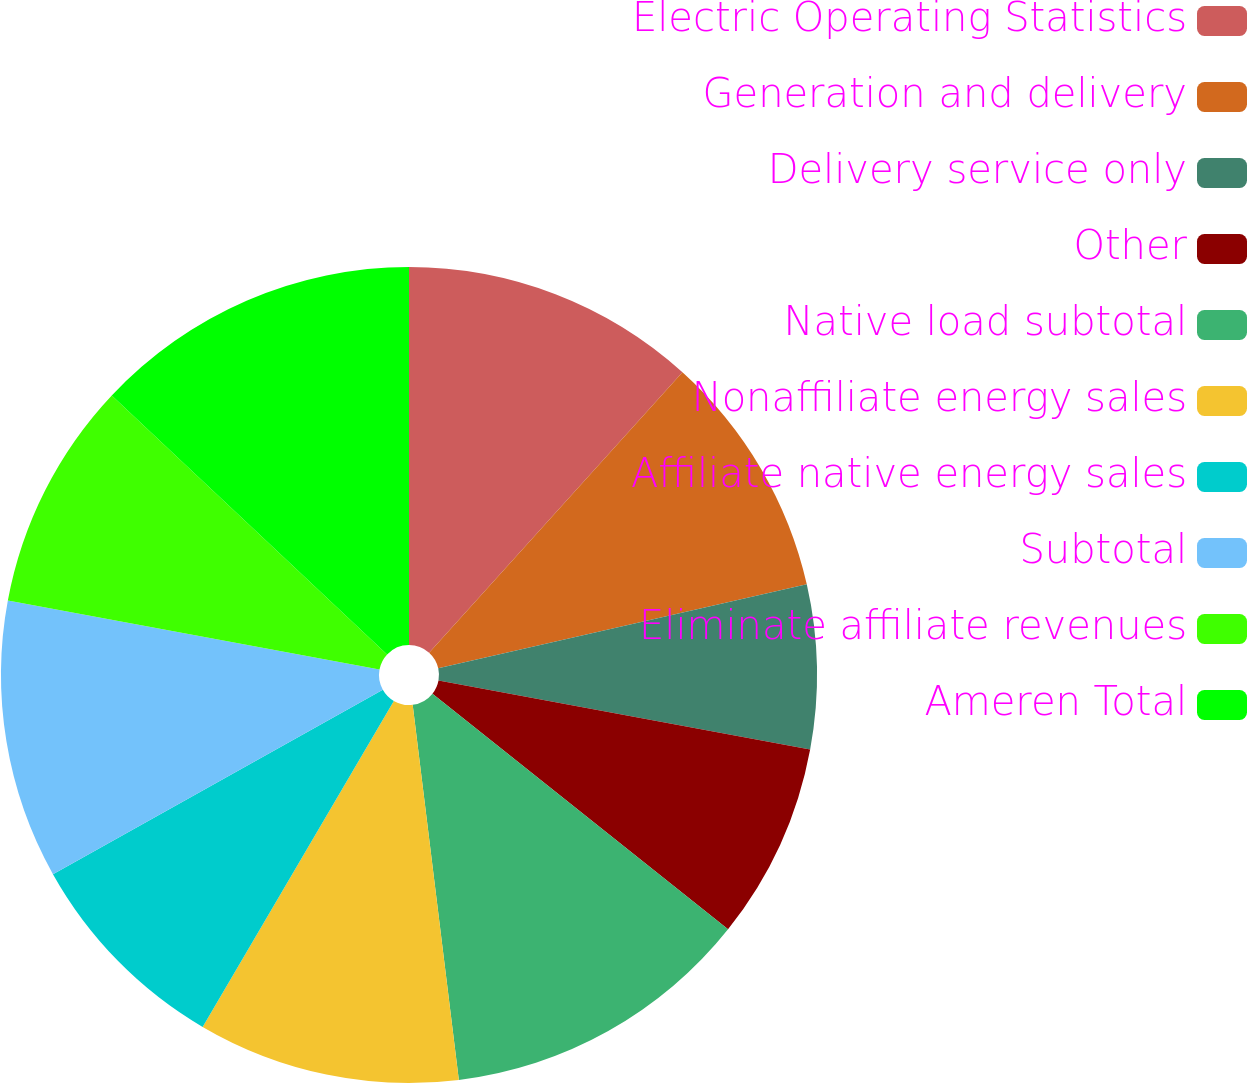Convert chart. <chart><loc_0><loc_0><loc_500><loc_500><pie_chart><fcel>Electric Operating Statistics<fcel>Generation and delivery<fcel>Delivery service only<fcel>Other<fcel>Native load subtotal<fcel>Nonaffiliate energy sales<fcel>Affiliate native energy sales<fcel>Subtotal<fcel>Eliminate affiliate revenues<fcel>Ameren Total<nl><fcel>11.69%<fcel>9.74%<fcel>6.49%<fcel>7.79%<fcel>12.34%<fcel>10.39%<fcel>8.44%<fcel>11.04%<fcel>9.09%<fcel>12.99%<nl></chart> 